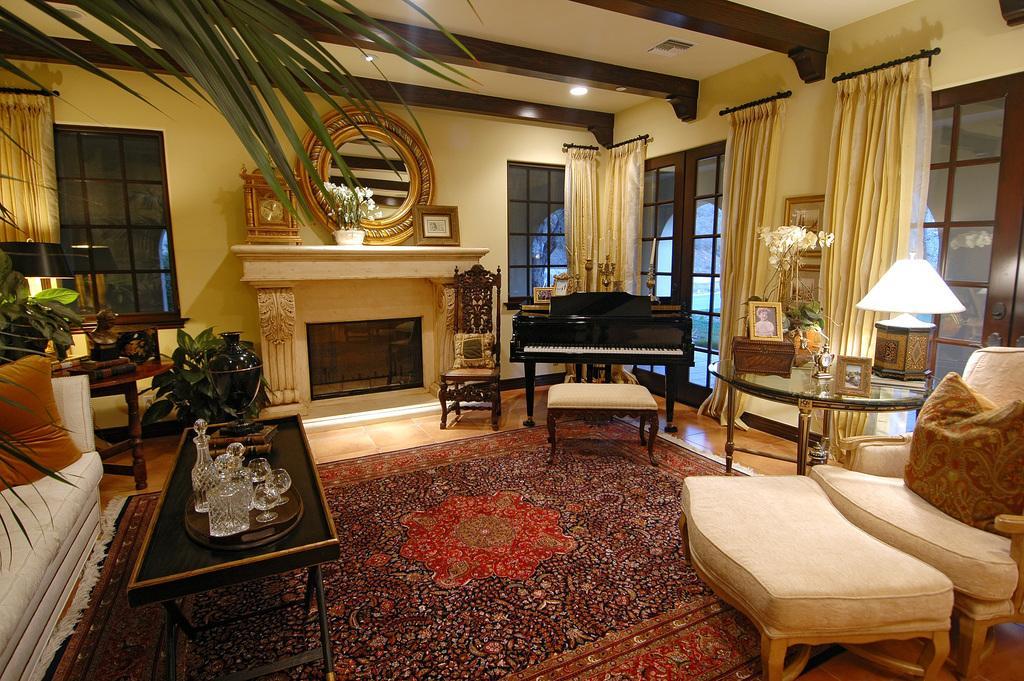Can you describe this image briefly? There is a room in which the carpet is on the floor. This room is well furnished with very good furniture. There is a lamp on the table and some photo frames. We can observe curtains here. There is a piano, in front of the piano there is a stool for playing it. Beside the piano there is a chair. Here is a place for camp fire. Above that place there is a flower pot. We can observe windows and wall in background. There are some trees inside the house and plants also. 